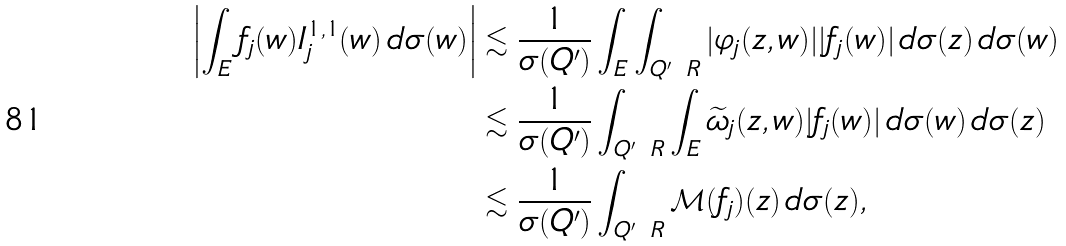<formula> <loc_0><loc_0><loc_500><loc_500>\left | \int _ { E } f _ { j } ( w ) I ^ { 1 , 1 } _ { j } ( w ) \, d \sigma ( w ) \right | & \lesssim \frac { 1 } { \sigma ( Q ^ { \prime } ) } \int _ { E } \int _ { Q ^ { \prime } \ R } | \varphi _ { j } ( z , w ) | | f _ { j } ( w ) | \, d \sigma ( z ) \, d \sigma ( w ) \\ & \lesssim \frac { 1 } { \sigma ( Q ^ { \prime } ) } \int _ { Q ^ { \prime } \ R } \int _ { E } \widetilde { \omega } _ { j } ( z , w ) | f _ { j } ( w ) | \, d \sigma ( w ) \, d \sigma ( z ) \\ & \lesssim \frac { 1 } { \sigma ( Q ^ { \prime } ) } \int _ { Q ^ { \prime } \ R } \mathcal { M } ( f _ { j } ) ( z ) \, d \sigma ( z ) ,</formula> 